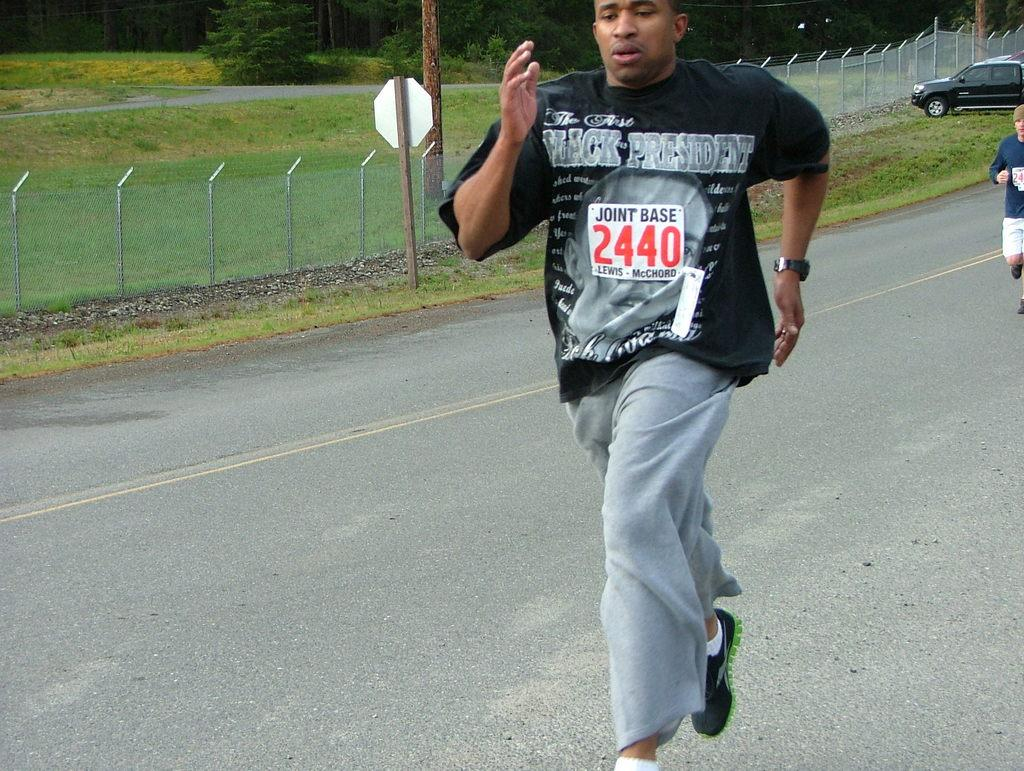What are the two persons in the image doing? The two persons in the image are running on the road. What type of natural elements can be seen in the image? There are trees, grass, and a fence in the image. What man-made structures are present in the image? There are poles, a board, and a vehicle in the image. What type of plantation can be seen in the image? There is no plantation present in the image. Can you tell me how many stones are visible in the image? There are no stones visible in the image. 